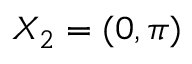Convert formula to latex. <formula><loc_0><loc_0><loc_500><loc_500>X _ { 2 } = ( 0 , \pi )</formula> 